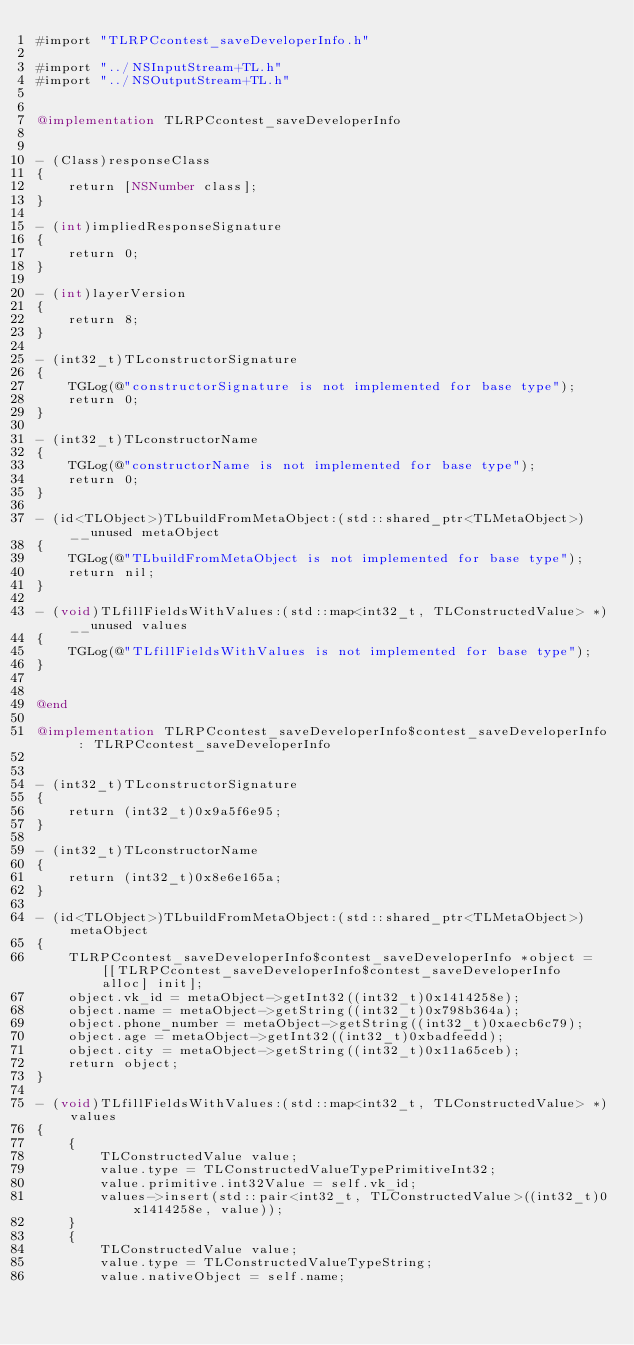<code> <loc_0><loc_0><loc_500><loc_500><_ObjectiveC_>#import "TLRPCcontest_saveDeveloperInfo.h"

#import "../NSInputStream+TL.h"
#import "../NSOutputStream+TL.h"


@implementation TLRPCcontest_saveDeveloperInfo


- (Class)responseClass
{
    return [NSNumber class];
}

- (int)impliedResponseSignature
{
    return 0;
}

- (int)layerVersion
{
    return 8;
}

- (int32_t)TLconstructorSignature
{
    TGLog(@"constructorSignature is not implemented for base type");
    return 0;
}

- (int32_t)TLconstructorName
{
    TGLog(@"constructorName is not implemented for base type");
    return 0;
}

- (id<TLObject>)TLbuildFromMetaObject:(std::shared_ptr<TLMetaObject>)__unused metaObject
{
    TGLog(@"TLbuildFromMetaObject is not implemented for base type");
    return nil;
}

- (void)TLfillFieldsWithValues:(std::map<int32_t, TLConstructedValue> *)__unused values
{
    TGLog(@"TLfillFieldsWithValues is not implemented for base type");
}


@end

@implementation TLRPCcontest_saveDeveloperInfo$contest_saveDeveloperInfo : TLRPCcontest_saveDeveloperInfo


- (int32_t)TLconstructorSignature
{
    return (int32_t)0x9a5f6e95;
}

- (int32_t)TLconstructorName
{
    return (int32_t)0x8e6e165a;
}

- (id<TLObject>)TLbuildFromMetaObject:(std::shared_ptr<TLMetaObject>)metaObject
{
    TLRPCcontest_saveDeveloperInfo$contest_saveDeveloperInfo *object = [[TLRPCcontest_saveDeveloperInfo$contest_saveDeveloperInfo alloc] init];
    object.vk_id = metaObject->getInt32((int32_t)0x1414258e);
    object.name = metaObject->getString((int32_t)0x798b364a);
    object.phone_number = metaObject->getString((int32_t)0xaecb6c79);
    object.age = metaObject->getInt32((int32_t)0xbadfeedd);
    object.city = metaObject->getString((int32_t)0x11a65ceb);
    return object;
}

- (void)TLfillFieldsWithValues:(std::map<int32_t, TLConstructedValue> *)values
{
    {
        TLConstructedValue value;
        value.type = TLConstructedValueTypePrimitiveInt32;
        value.primitive.int32Value = self.vk_id;
        values->insert(std::pair<int32_t, TLConstructedValue>((int32_t)0x1414258e, value));
    }
    {
        TLConstructedValue value;
        value.type = TLConstructedValueTypeString;
        value.nativeObject = self.name;</code> 